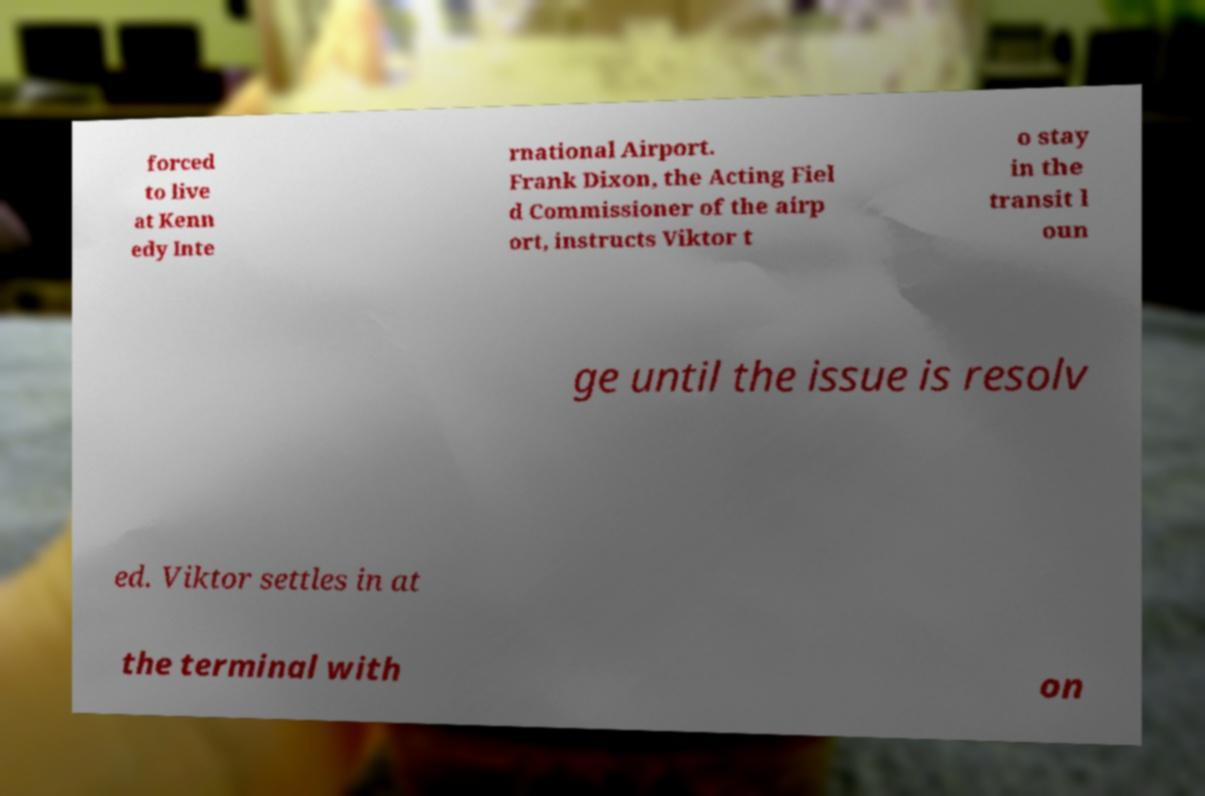For documentation purposes, I need the text within this image transcribed. Could you provide that? forced to live at Kenn edy Inte rnational Airport. Frank Dixon, the Acting Fiel d Commissioner of the airp ort, instructs Viktor t o stay in the transit l oun ge until the issue is resolv ed. Viktor settles in at the terminal with on 